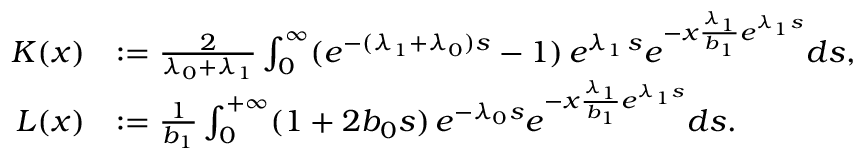<formula> <loc_0><loc_0><loc_500><loc_500>\begin{array} { r l } { K ( x ) } & { \colon = \frac { 2 } { \lambda _ { 0 } + \lambda _ { 1 } } \int _ { 0 } ^ { \infty } ( e ^ { - ( \lambda _ { 1 } + \lambda _ { 0 } ) s } - 1 ) \, e ^ { \lambda _ { 1 } \, s } e ^ { - x \frac { \lambda _ { 1 } } { b _ { 1 } } e ^ { \lambda _ { 1 } s } } d s , } \\ { L ( x ) } & { \colon = \frac { 1 } { b _ { 1 } } \int _ { 0 } ^ { + \infty } ( 1 + 2 b _ { 0 } s ) \, e ^ { - \lambda _ { 0 } s } e ^ { - x \frac { \lambda _ { 1 } } { b _ { 1 } } e ^ { \lambda _ { 1 } s } } d s . } \end{array}</formula> 